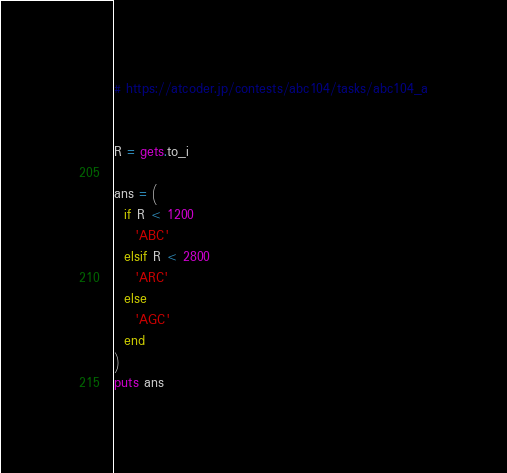<code> <loc_0><loc_0><loc_500><loc_500><_Ruby_># https://atcoder.jp/contests/abc104/tasks/abc104_a


R = gets.to_i

ans = (
  if R < 1200
    'ABC'
  elsif R < 2800
    'ARC'
  else
    'AGC'
  end
)
puts ans
</code> 